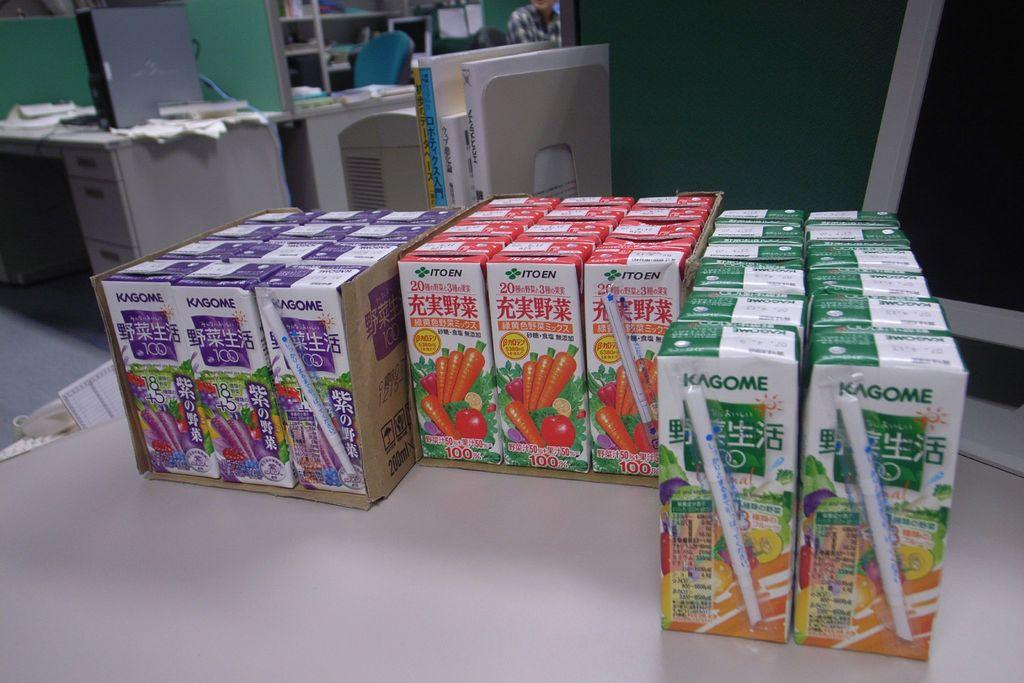<image>
Render a clear and concise summary of the photo. the word kagome that is on some cases of juice 